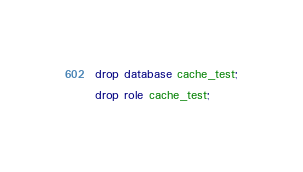<code> <loc_0><loc_0><loc_500><loc_500><_SQL_>drop database cache_test;
drop role cache_test;</code> 